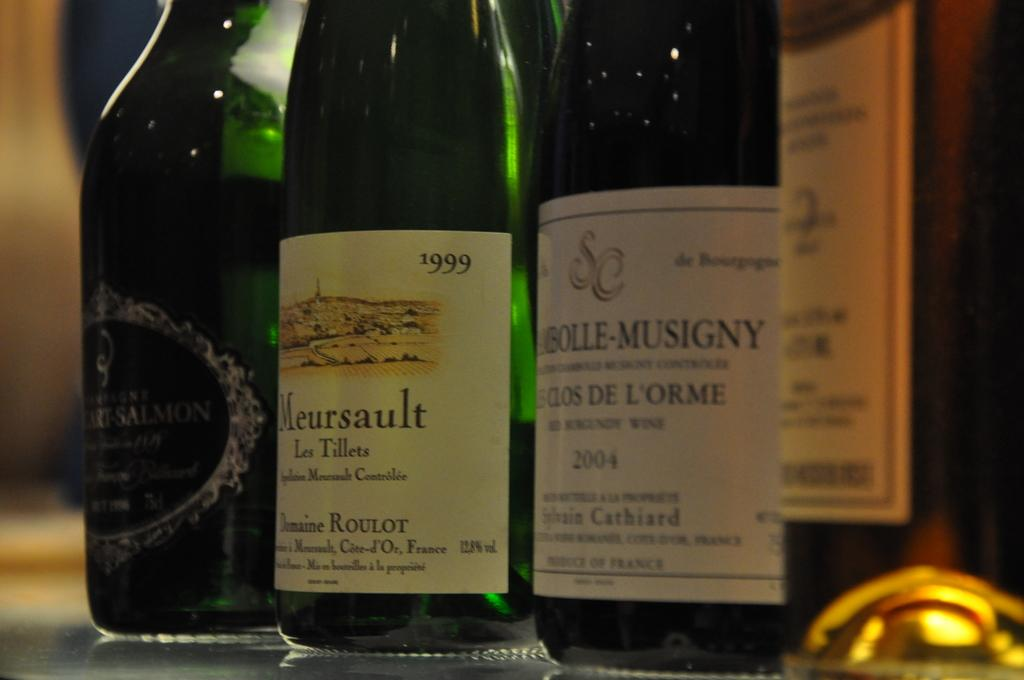Provide a one-sentence caption for the provided image. Several bottles of wine on a table one called Meursault. 